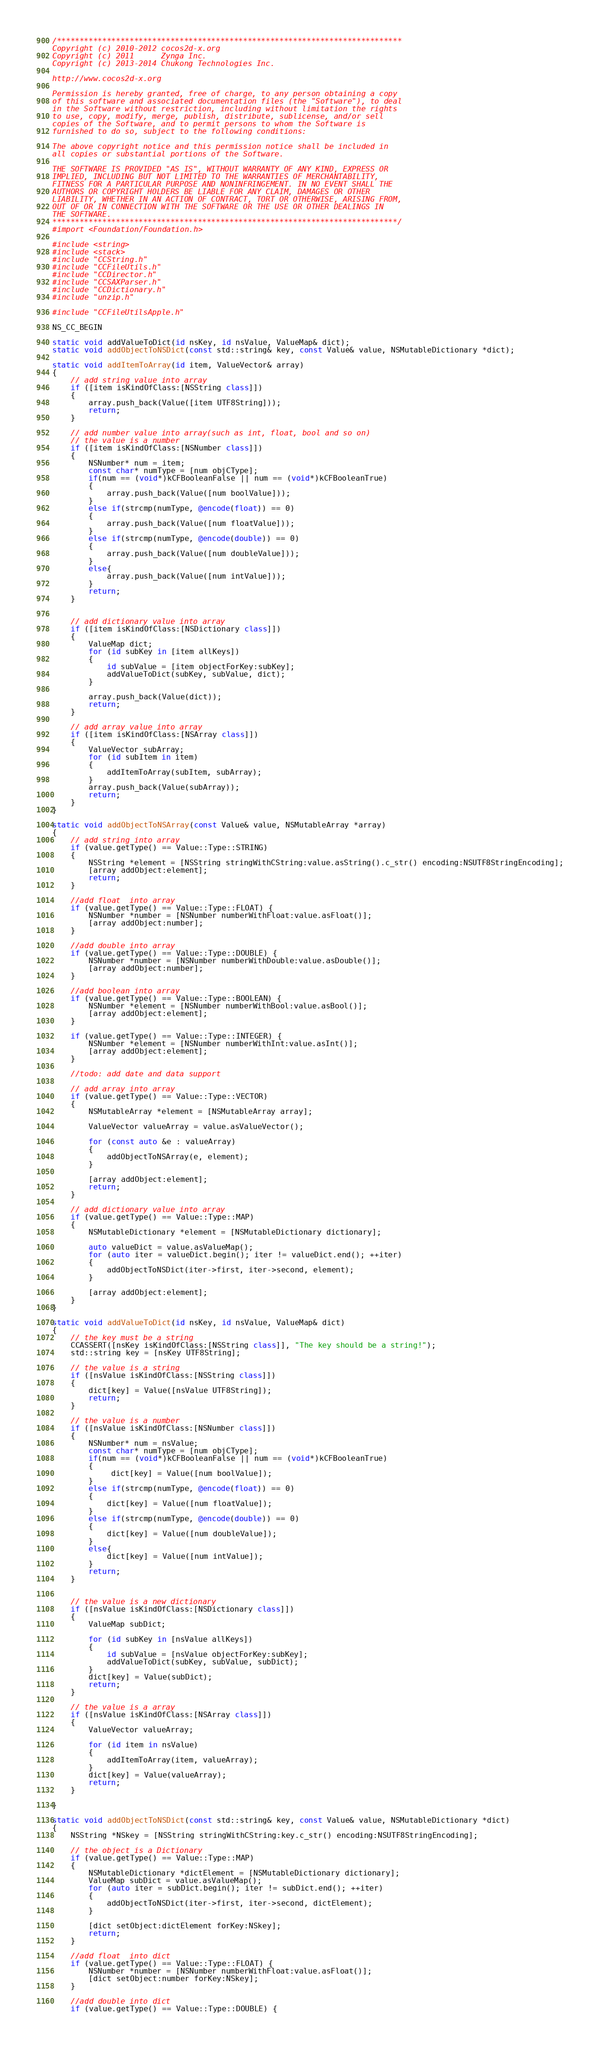Convert code to text. <code><loc_0><loc_0><loc_500><loc_500><_ObjectiveC_>/****************************************************************************
Copyright (c) 2010-2012 cocos2d-x.org
Copyright (c) 2011      Zynga Inc.
Copyright (c) 2013-2014 Chukong Technologies Inc.

http://www.cocos2d-x.org

Permission is hereby granted, free of charge, to any person obtaining a copy
of this software and associated documentation files (the "Software"), to deal
in the Software without restriction, including without limitation the rights
to use, copy, modify, merge, publish, distribute, sublicense, and/or sell
copies of the Software, and to permit persons to whom the Software is
furnished to do so, subject to the following conditions:

The above copyright notice and this permission notice shall be included in
all copies or substantial portions of the Software.

THE SOFTWARE IS PROVIDED "AS IS", WITHOUT WARRANTY OF ANY KIND, EXPRESS OR
IMPLIED, INCLUDING BUT NOT LIMITED TO THE WARRANTIES OF MERCHANTABILITY,
FITNESS FOR A PARTICULAR PURPOSE AND NONINFRINGEMENT. IN NO EVENT SHALL THE
AUTHORS OR COPYRIGHT HOLDERS BE LIABLE FOR ANY CLAIM, DAMAGES OR OTHER
LIABILITY, WHETHER IN AN ACTION OF CONTRACT, TORT OR OTHERWISE, ARISING FROM,
OUT OF OR IN CONNECTION WITH THE SOFTWARE OR THE USE OR OTHER DEALINGS IN
THE SOFTWARE.
****************************************************************************/
#import <Foundation/Foundation.h>

#include <string>
#include <stack>
#include "CCString.h"
#include "CCFileUtils.h"
#include "CCDirector.h"
#include "CCSAXParser.h"
#include "CCDictionary.h"
#include "unzip.h"

#include "CCFileUtilsApple.h"

NS_CC_BEGIN

static void addValueToDict(id nsKey, id nsValue, ValueMap& dict);
static void addObjectToNSDict(const std::string& key, const Value& value, NSMutableDictionary *dict);

static void addItemToArray(id item, ValueVector& array)
{
    // add string value into array
    if ([item isKindOfClass:[NSString class]])
    {
        array.push_back(Value([item UTF8String]));
        return;
    }
    
    // add number value into array(such as int, float, bool and so on)
    // the value is a number
    if ([item isKindOfClass:[NSNumber class]])
    {
        NSNumber* num = item;
        const char* numType = [num objCType];
        if(num == (void*)kCFBooleanFalse || num == (void*)kCFBooleanTrue)
        {
            array.push_back(Value([num boolValue]));
        }
        else if(strcmp(numType, @encode(float)) == 0)
        {
            array.push_back(Value([num floatValue]));
        }
        else if(strcmp(numType, @encode(double)) == 0)
        {
            array.push_back(Value([num doubleValue]));
        }
        else{
            array.push_back(Value([num intValue]));
        }
        return;
    }

    
    // add dictionary value into array
    if ([item isKindOfClass:[NSDictionary class]])
    {
        ValueMap dict;
        for (id subKey in [item allKeys])
        {
            id subValue = [item objectForKey:subKey];
            addValueToDict(subKey, subValue, dict);
        }
        
        array.push_back(Value(dict));
        return;
    }
    
    // add array value into array
    if ([item isKindOfClass:[NSArray class]])
    {
        ValueVector subArray;
        for (id subItem in item)
        {
            addItemToArray(subItem, subArray);
        }
        array.push_back(Value(subArray));
        return;
    }
}

static void addObjectToNSArray(const Value& value, NSMutableArray *array)
{
    // add string into array
    if (value.getType() == Value::Type::STRING)
    {
        NSString *element = [NSString stringWithCString:value.asString().c_str() encoding:NSUTF8StringEncoding];
        [array addObject:element];
        return;
    }
    
    //add float  into array
    if (value.getType() == Value::Type::FLOAT) {
        NSNumber *number = [NSNumber numberWithFloat:value.asFloat()];
        [array addObject:number];
    }
    
    //add double into array
    if (value.getType() == Value::Type::DOUBLE) {
        NSNumber *number = [NSNumber numberWithDouble:value.asDouble()];
        [array addObject:number];
    }
    
    //add boolean into array
    if (value.getType() == Value::Type::BOOLEAN) {
        NSNumber *element = [NSNumber numberWithBool:value.asBool()];
        [array addObject:element];
    }
    
    if (value.getType() == Value::Type::INTEGER) {
        NSNumber *element = [NSNumber numberWithInt:value.asInt()];
        [array addObject:element];
    }
    
    //todo: add date and data support
    
    // add array into array
    if (value.getType() == Value::Type::VECTOR)
    {
        NSMutableArray *element = [NSMutableArray array];
        
        ValueVector valueArray = value.asValueVector();
        
        for (const auto &e : valueArray)
        {
            addObjectToNSArray(e, element);
        }
        
        [array addObject:element];
        return;
    }
    
    // add dictionary value into array
    if (value.getType() == Value::Type::MAP)
    {
        NSMutableDictionary *element = [NSMutableDictionary dictionary];

        auto valueDict = value.asValueMap();
        for (auto iter = valueDict.begin(); iter != valueDict.end(); ++iter)
        {
            addObjectToNSDict(iter->first, iter->second, element);
        }
        
        [array addObject:element];
    }
}

static void addValueToDict(id nsKey, id nsValue, ValueMap& dict)
{
    // the key must be a string
    CCASSERT([nsKey isKindOfClass:[NSString class]], "The key should be a string!");
    std::string key = [nsKey UTF8String];
    
    // the value is a string
    if ([nsValue isKindOfClass:[NSString class]])
    {
        dict[key] = Value([nsValue UTF8String]);
        return;
    }
    
    // the value is a number
    if ([nsValue isKindOfClass:[NSNumber class]])
    {
        NSNumber* num = nsValue;
        const char* numType = [num objCType];
        if(num == (void*)kCFBooleanFalse || num == (void*)kCFBooleanTrue)
        {
             dict[key] = Value([num boolValue]);
        }
        else if(strcmp(numType, @encode(float)) == 0)
        {
            dict[key] = Value([num floatValue]);
        }
        else if(strcmp(numType, @encode(double)) == 0)
        {
            dict[key] = Value([num doubleValue]);
        }
        else{
            dict[key] = Value([num intValue]);
        }
        return;
    }

    
    // the value is a new dictionary
    if ([nsValue isKindOfClass:[NSDictionary class]])
    {
        ValueMap subDict;
        
        for (id subKey in [nsValue allKeys])
        {
            id subValue = [nsValue objectForKey:subKey];
            addValueToDict(subKey, subValue, subDict);
        }
        dict[key] = Value(subDict);
        return;
    }
    
    // the value is a array
    if ([nsValue isKindOfClass:[NSArray class]])
    {
        ValueVector valueArray;

        for (id item in nsValue)
        {
            addItemToArray(item, valueArray);
        }
        dict[key] = Value(valueArray);
        return;
    }
    
}

static void addObjectToNSDict(const std::string& key, const Value& value, NSMutableDictionary *dict)
{
    NSString *NSkey = [NSString stringWithCString:key.c_str() encoding:NSUTF8StringEncoding];
    
    // the object is a Dictionary
    if (value.getType() == Value::Type::MAP)
    {
        NSMutableDictionary *dictElement = [NSMutableDictionary dictionary];
        ValueMap subDict = value.asValueMap();
        for (auto iter = subDict.begin(); iter != subDict.end(); ++iter)
        {
            addObjectToNSDict(iter->first, iter->second, dictElement);
        }
        
        [dict setObject:dictElement forKey:NSkey];
        return;
    }
    
    //add float  into dict
    if (value.getType() == Value::Type::FLOAT) {
        NSNumber *number = [NSNumber numberWithFloat:value.asFloat()];
        [dict setObject:number forKey:NSkey];
    }
    
    //add double into dict
    if (value.getType() == Value::Type::DOUBLE) {</code> 